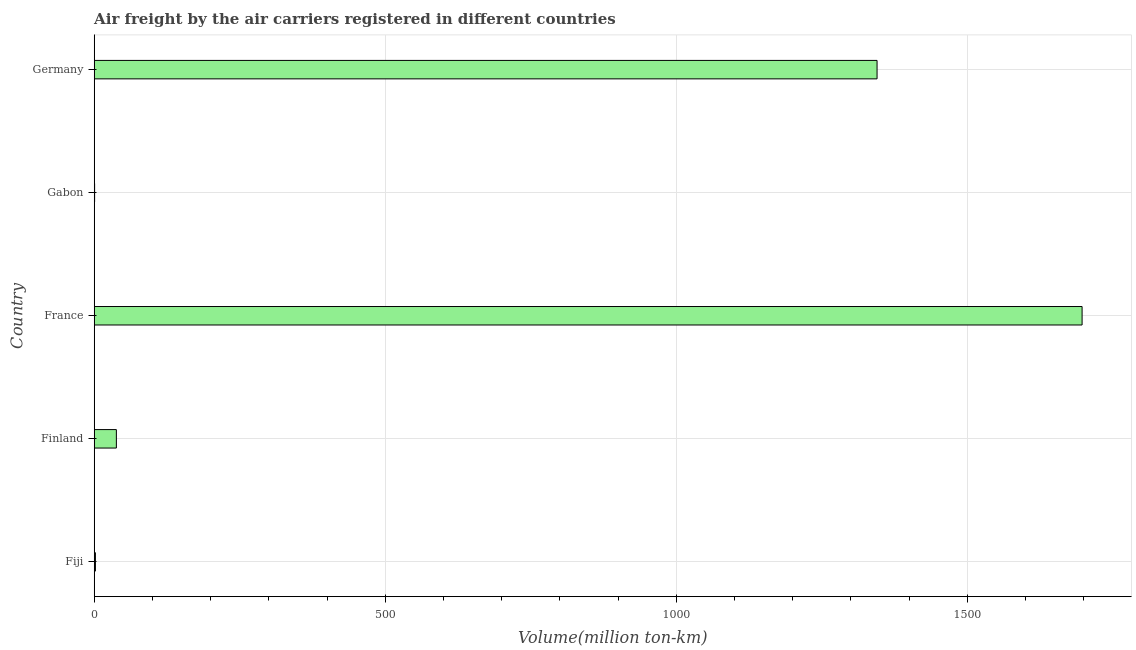Does the graph contain any zero values?
Keep it short and to the point. No. Does the graph contain grids?
Offer a terse response. Yes. What is the title of the graph?
Provide a succinct answer. Air freight by the air carriers registered in different countries. What is the label or title of the X-axis?
Offer a very short reply. Volume(million ton-km). What is the label or title of the Y-axis?
Make the answer very short. Country. What is the air freight in Finland?
Offer a very short reply. 38.1. Across all countries, what is the maximum air freight?
Provide a succinct answer. 1697. Across all countries, what is the minimum air freight?
Provide a short and direct response. 0.7. In which country was the air freight maximum?
Ensure brevity in your answer.  France. In which country was the air freight minimum?
Keep it short and to the point. Gabon. What is the sum of the air freight?
Provide a short and direct response. 3082.7. What is the difference between the air freight in Fiji and France?
Keep it short and to the point. -1694.9. What is the average air freight per country?
Provide a short and direct response. 616.54. What is the median air freight?
Your answer should be compact. 38.1. In how many countries, is the air freight greater than 1300 million ton-km?
Give a very brief answer. 2. What is the ratio of the air freight in Gabon to that in Germany?
Ensure brevity in your answer.  0. Is the difference between the air freight in France and Germany greater than the difference between any two countries?
Keep it short and to the point. No. What is the difference between the highest and the second highest air freight?
Provide a succinct answer. 352.2. What is the difference between the highest and the lowest air freight?
Provide a short and direct response. 1696.3. In how many countries, is the air freight greater than the average air freight taken over all countries?
Give a very brief answer. 2. How many bars are there?
Provide a short and direct response. 5. Are all the bars in the graph horizontal?
Ensure brevity in your answer.  Yes. What is the Volume(million ton-km) of Fiji?
Provide a succinct answer. 2.1. What is the Volume(million ton-km) in Finland?
Offer a terse response. 38.1. What is the Volume(million ton-km) of France?
Ensure brevity in your answer.  1697. What is the Volume(million ton-km) of Gabon?
Give a very brief answer. 0.7. What is the Volume(million ton-km) in Germany?
Offer a very short reply. 1344.8. What is the difference between the Volume(million ton-km) in Fiji and Finland?
Make the answer very short. -36. What is the difference between the Volume(million ton-km) in Fiji and France?
Ensure brevity in your answer.  -1694.9. What is the difference between the Volume(million ton-km) in Fiji and Gabon?
Your response must be concise. 1.4. What is the difference between the Volume(million ton-km) in Fiji and Germany?
Your answer should be very brief. -1342.7. What is the difference between the Volume(million ton-km) in Finland and France?
Your response must be concise. -1658.9. What is the difference between the Volume(million ton-km) in Finland and Gabon?
Your response must be concise. 37.4. What is the difference between the Volume(million ton-km) in Finland and Germany?
Make the answer very short. -1306.7. What is the difference between the Volume(million ton-km) in France and Gabon?
Your answer should be very brief. 1696.3. What is the difference between the Volume(million ton-km) in France and Germany?
Your answer should be very brief. 352.2. What is the difference between the Volume(million ton-km) in Gabon and Germany?
Keep it short and to the point. -1344.1. What is the ratio of the Volume(million ton-km) in Fiji to that in Finland?
Offer a terse response. 0.06. What is the ratio of the Volume(million ton-km) in Fiji to that in Germany?
Your answer should be compact. 0. What is the ratio of the Volume(million ton-km) in Finland to that in France?
Provide a succinct answer. 0.02. What is the ratio of the Volume(million ton-km) in Finland to that in Gabon?
Provide a succinct answer. 54.43. What is the ratio of the Volume(million ton-km) in Finland to that in Germany?
Offer a very short reply. 0.03. What is the ratio of the Volume(million ton-km) in France to that in Gabon?
Provide a short and direct response. 2424.29. What is the ratio of the Volume(million ton-km) in France to that in Germany?
Your response must be concise. 1.26. What is the ratio of the Volume(million ton-km) in Gabon to that in Germany?
Make the answer very short. 0. 